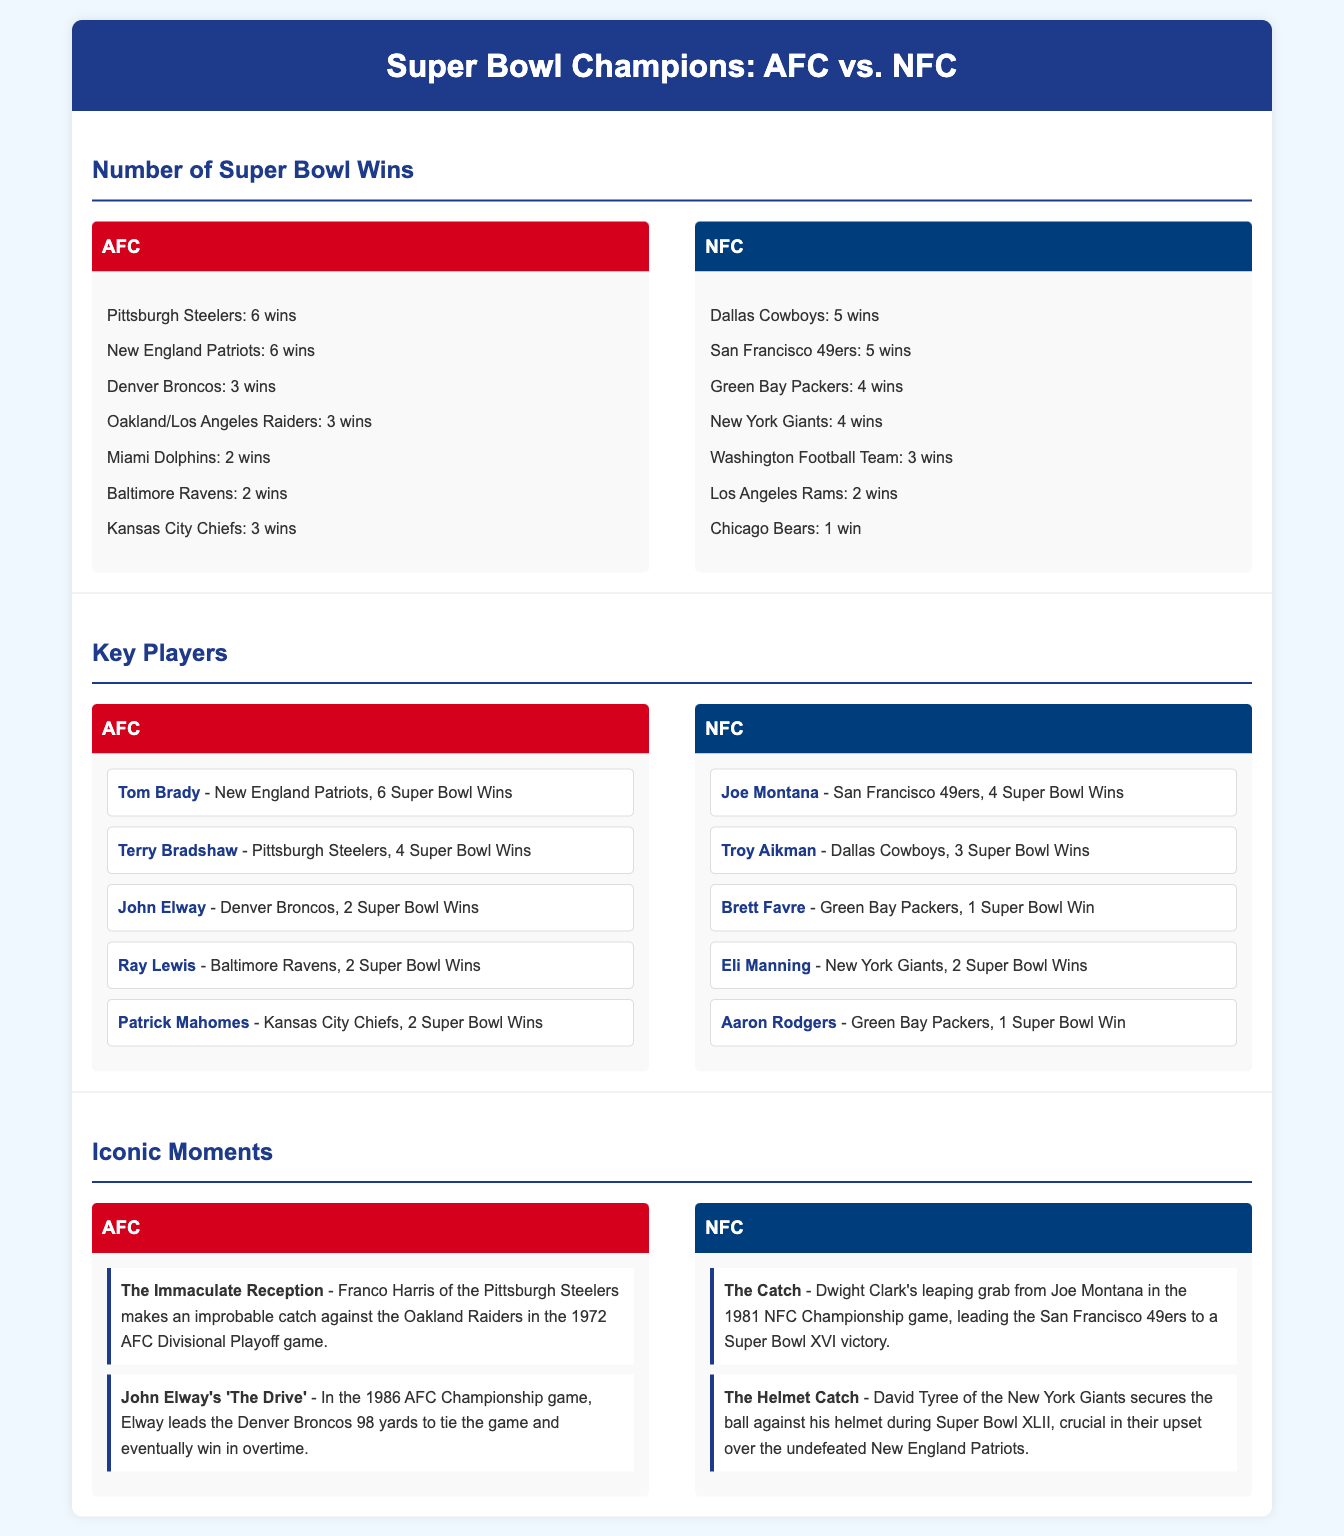What is the total number of Super Bowl wins for the AFC? The total number of Super Bowl wins for the AFC is the sum of all wins by its teams: 6 + 6 + 3 + 3 + 2 + 2 + 3 = 25.
Answer: 25 What are the total Super Bowl wins for the NFC? The total number of Super Bowl wins for the NFC is the sum of all wins by its teams: 5 + 5 + 4 + 4 + 3 + 2 + 1 = 24.
Answer: 24 Who is the player with the most Super Bowl wins in the AFC? The player with the most Super Bowl wins in the AFC is Tom Brady with 6 Super Bowl wins.
Answer: Tom Brady Which team has the most Super Bowl wins in the NFC? The team with the most Super Bowl wins in the NFC is the Dallas Cowboys and San Francisco 49ers, each with 5 wins.
Answer: Dallas Cowboys and San Francisco 49ers What is an iconic moment from the AFC? An iconic moment from the AFC is "The Immaculate Reception" by Franco Harris.
Answer: The Immaculate Reception What is an iconic moment from the NFC? An iconic moment from the NFC is "The Catch" by Dwight Clark.
Answer: The Catch How many Super Bowl wins does Patrick Mahomes have? Patrick Mahomes has 2 Super Bowl wins.
Answer: 2 What year did "The Drive" happen? "The Drive" happened in 1986 during the AFC Championship game.
Answer: 1986 Which player from the NFC has 3 Super Bowl wins? The player from the NFC who has 3 Super Bowl wins is Troy Aikman.
Answer: Troy Aikman What was significant about Super Bowl XLII for the NFC? Super Bowl XLII was significant for the NFC as it featured "The Helmet Catch" by David Tyree.
Answer: The Helmet Catch 